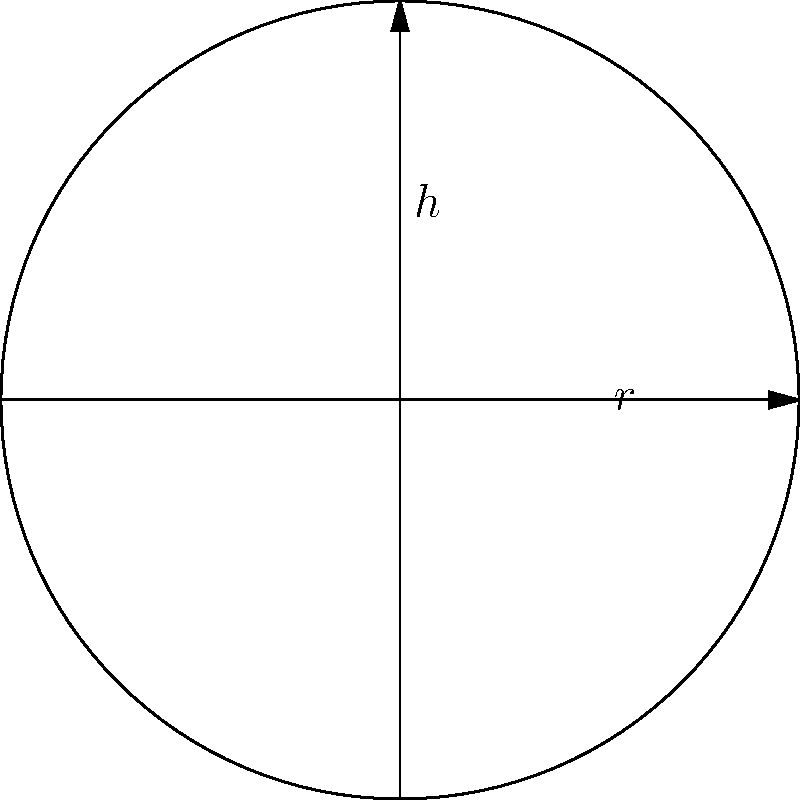You are preparing a cylindrical cake pan for a charity event. The pan has a radius of 6 inches and a height of 8 inches. Using the formula for the volume of a cylinder, $V = \pi r^2 h$, calculate the volume of the cake pan. Round your answer to the nearest cubic inch. To calculate the volume of the cylindrical cake pan, we'll use the formula $V = \pi r^2 h$, where:
$V$ = volume
$\pi$ = pi (approximately 3.14159)
$r$ = radius
$h$ = height

Given:
- Radius ($r$) = 6 inches
- Height ($h$) = 8 inches

Step 1: Substitute the values into the formula
$V = \pi (6\text{ in})^2 (8\text{ in})$

Step 2: Calculate the square of the radius
$V = \pi (36\text{ in}^2) (8\text{ in})$

Step 3: Multiply the terms
$V = 288\pi\text{ in}^3$

Step 4: Use 3.14159 for $\pi$ and calculate
$V = 288 \times 3.14159\text{ in}^3$
$V = 904.77792\text{ in}^3$

Step 5: Round to the nearest cubic inch
$V \approx 905\text{ in}^3$

Therefore, the volume of the cylindrical cake pan is approximately 905 cubic inches.
Answer: $905\text{ in}^3$ 